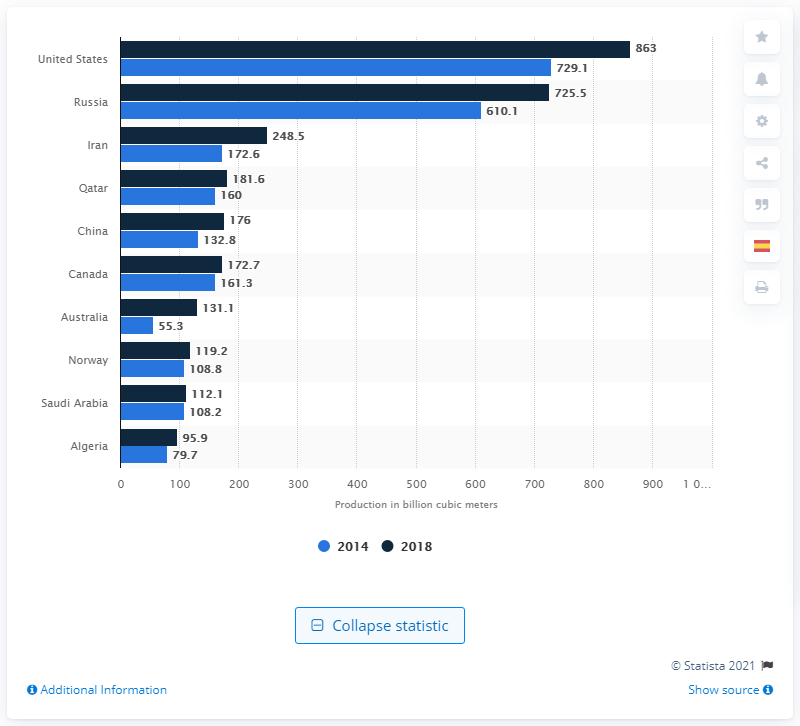Highlight a few significant elements in this photo. In 2018, Russia was the second largest natural gas producer in the world, producing a significant amount of natural gas. In 2018, the United States produced approximately 863 cubic meters of natural gas. 